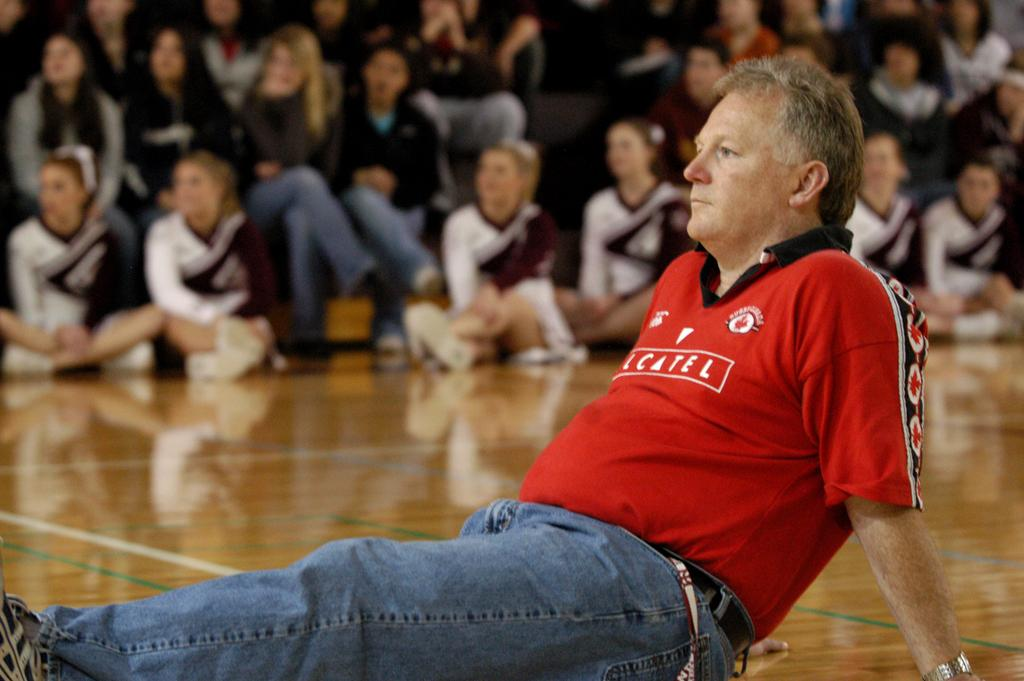What are the people in the image doing? The people in the image are sitting on the floor. Can you describe the setting in the image? There are people sitting in the background of the image. What type of books are the people reading in the image? There are no books visible in the image; the people are sitting on the floor and in the background. 